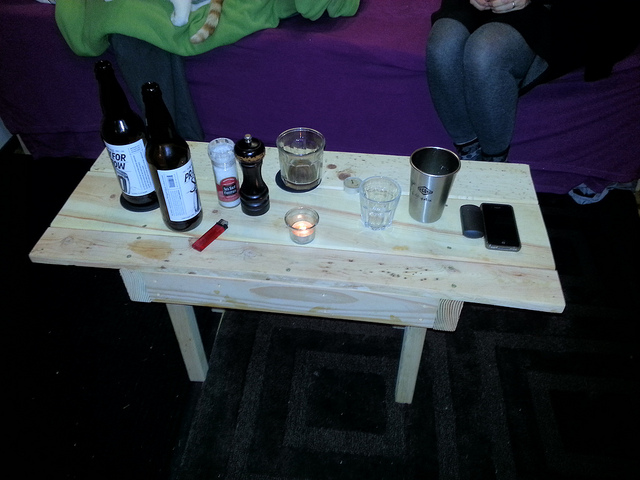What items are on the table aside from the bottles? Besides the bottles, the table hosts a collection of everyday items: a thermos which appears well-used, possibly for coffee or tea, a transparent glass cup, a small tealight candle radiating a quiet glow, a red lighter, and a smartphone, likely used for capturing moments or communication. This setting suggests a casual gathering, perhaps in a cozy, informal setting. 